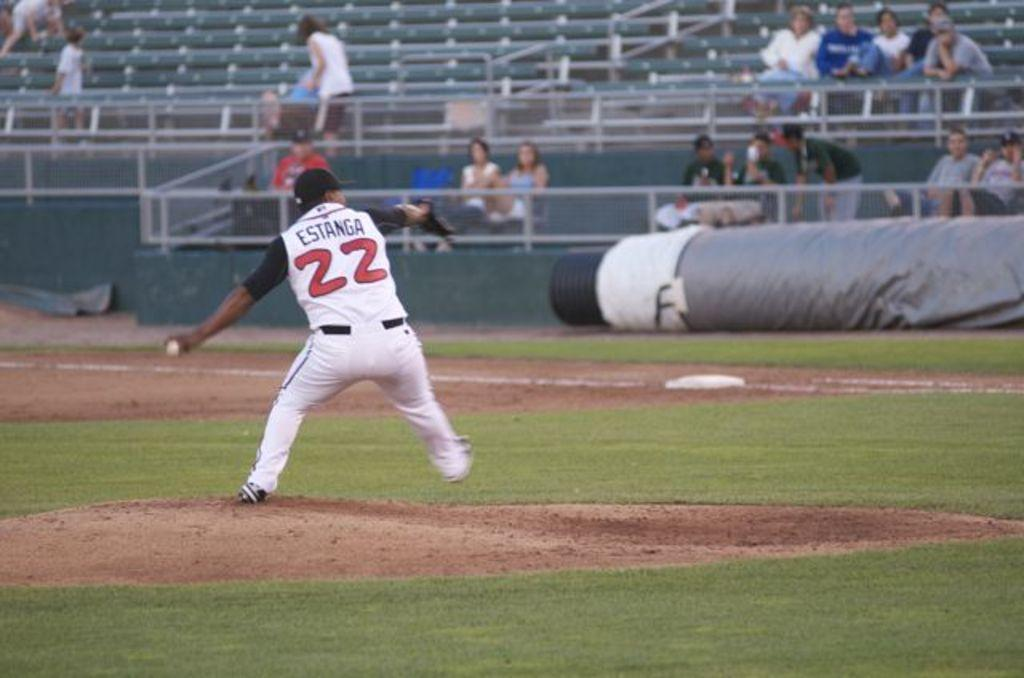<image>
Write a terse but informative summary of the picture. A man wearing a jersey that says Estanga 22 on a baseball field. 